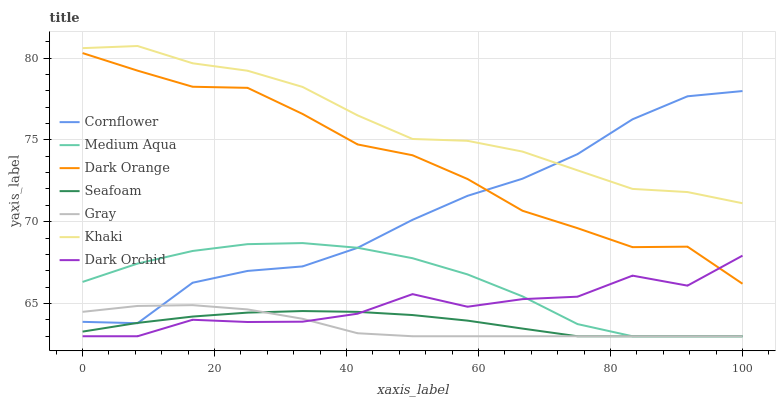Does Gray have the minimum area under the curve?
Answer yes or no. Yes. Does Khaki have the maximum area under the curve?
Answer yes or no. Yes. Does Khaki have the minimum area under the curve?
Answer yes or no. No. Does Gray have the maximum area under the curve?
Answer yes or no. No. Is Seafoam the smoothest?
Answer yes or no. Yes. Is Dark Orchid the roughest?
Answer yes or no. Yes. Is Khaki the smoothest?
Answer yes or no. No. Is Khaki the roughest?
Answer yes or no. No. Does Gray have the lowest value?
Answer yes or no. Yes. Does Khaki have the lowest value?
Answer yes or no. No. Does Khaki have the highest value?
Answer yes or no. Yes. Does Gray have the highest value?
Answer yes or no. No. Is Dark Orchid less than Khaki?
Answer yes or no. Yes. Is Dark Orange greater than Medium Aqua?
Answer yes or no. Yes. Does Dark Orchid intersect Medium Aqua?
Answer yes or no. Yes. Is Dark Orchid less than Medium Aqua?
Answer yes or no. No. Is Dark Orchid greater than Medium Aqua?
Answer yes or no. No. Does Dark Orchid intersect Khaki?
Answer yes or no. No. 